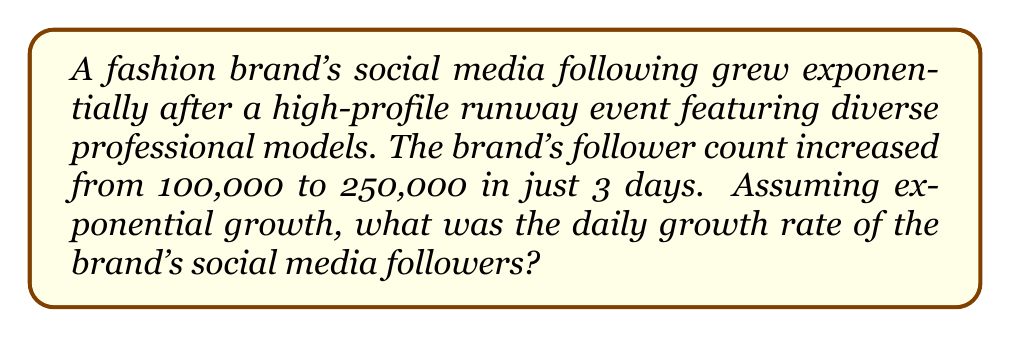Help me with this question. Let's approach this step-by-step using the exponential growth formula:

1) The exponential growth formula is:
   $A = P(1 + r)^t$
   Where:
   $A$ = Final amount
   $P$ = Initial amount
   $r$ = Growth rate (as a decimal)
   $t$ = Time period

2) We know:
   $P = 100,000$ (initial followers)
   $A = 250,000$ (final followers)
   $t = 3$ (days)

3) Let's plug these into our formula:
   $250,000 = 100,000(1 + r)^3$

4) Divide both sides by 100,000:
   $2.5 = (1 + r)^3$

5) Take the cube root of both sides:
   $\sqrt[3]{2.5} = 1 + r$

6) Subtract 1 from both sides:
   $\sqrt[3]{2.5} - 1 = r$

7) Calculate:
   $r \approx 1.357 - 1 = 0.357$

8) Convert to a percentage:
   $0.357 \times 100\% = 35.7\%$

Therefore, the daily growth rate was approximately 35.7%.
Answer: 35.7% 